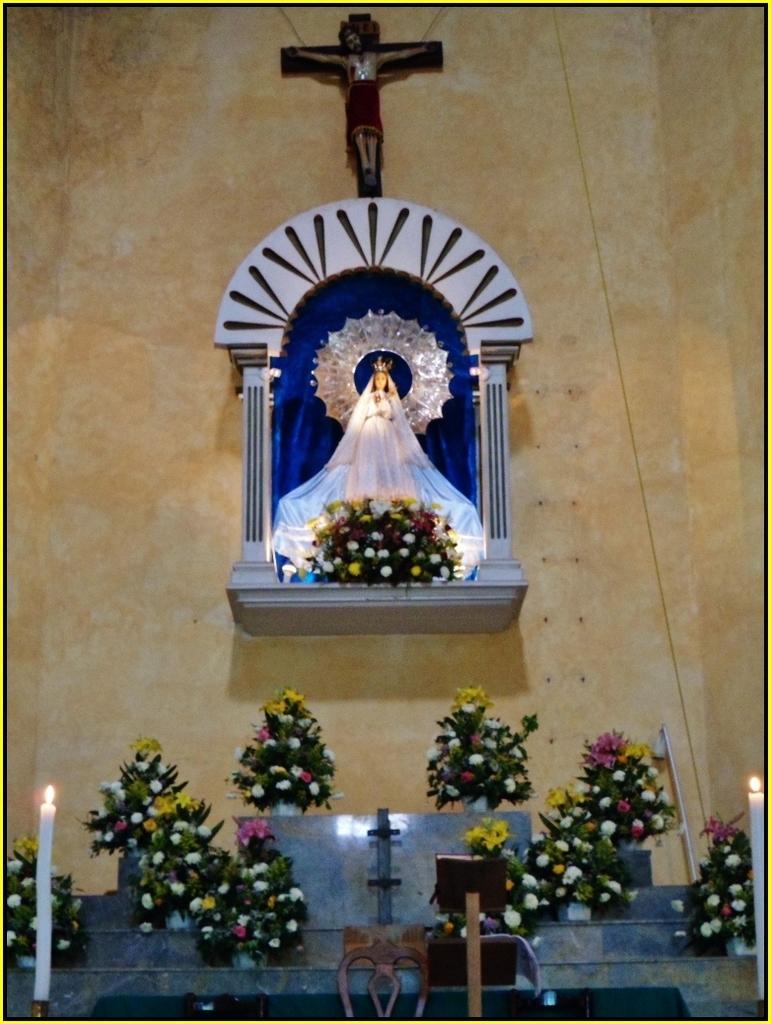Please provide a concise description of this image. In this image we can see some sculptures on the wall in front of it there are flower bouquets, candles and a few other objects. 